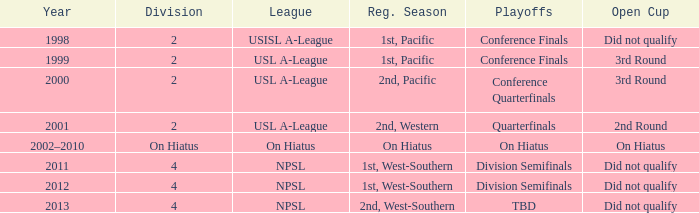Which playoff events happened in 2011? Division Semifinals. 